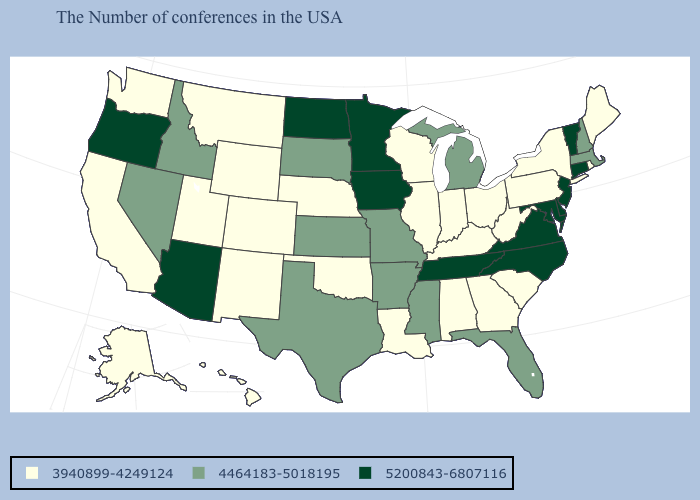What is the lowest value in the USA?
Write a very short answer. 3940899-4249124. How many symbols are there in the legend?
Keep it brief. 3. Which states have the lowest value in the USA?
Be succinct. Maine, Rhode Island, New York, Pennsylvania, South Carolina, West Virginia, Ohio, Georgia, Kentucky, Indiana, Alabama, Wisconsin, Illinois, Louisiana, Nebraska, Oklahoma, Wyoming, Colorado, New Mexico, Utah, Montana, California, Washington, Alaska, Hawaii. Is the legend a continuous bar?
Quick response, please. No. Among the states that border Wisconsin , which have the lowest value?
Concise answer only. Illinois. Among the states that border Illinois , does Iowa have the highest value?
Answer briefly. Yes. Name the states that have a value in the range 5200843-6807116?
Short answer required. Vermont, Connecticut, New Jersey, Delaware, Maryland, Virginia, North Carolina, Tennessee, Minnesota, Iowa, North Dakota, Arizona, Oregon. Name the states that have a value in the range 5200843-6807116?
Short answer required. Vermont, Connecticut, New Jersey, Delaware, Maryland, Virginia, North Carolina, Tennessee, Minnesota, Iowa, North Dakota, Arizona, Oregon. What is the value of Maine?
Write a very short answer. 3940899-4249124. Name the states that have a value in the range 4464183-5018195?
Be succinct. Massachusetts, New Hampshire, Florida, Michigan, Mississippi, Missouri, Arkansas, Kansas, Texas, South Dakota, Idaho, Nevada. Name the states that have a value in the range 4464183-5018195?
Give a very brief answer. Massachusetts, New Hampshire, Florida, Michigan, Mississippi, Missouri, Arkansas, Kansas, Texas, South Dakota, Idaho, Nevada. Among the states that border Indiana , which have the lowest value?
Concise answer only. Ohio, Kentucky, Illinois. Does the first symbol in the legend represent the smallest category?
Quick response, please. Yes. Among the states that border South Dakota , does North Dakota have the highest value?
Short answer required. Yes. What is the highest value in the USA?
Answer briefly. 5200843-6807116. 